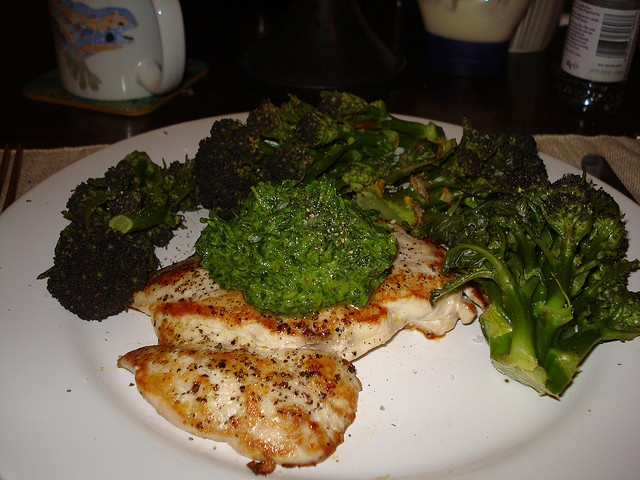Describe the objects in this image and their specific colors. I can see dining table in black, darkgray, darkgreen, gray, and lightgray tones, broccoli in black, darkgreen, and darkgray tones, broccoli in black, darkgreen, and olive tones, pizza in black, olive, and tan tones, and broccoli in black, darkgreen, and gray tones in this image. 